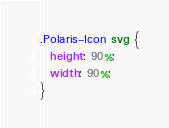<code> <loc_0><loc_0><loc_500><loc_500><_CSS_>.Polaris-Icon svg {
  height: 90%;
  width: 90%;
}
</code> 